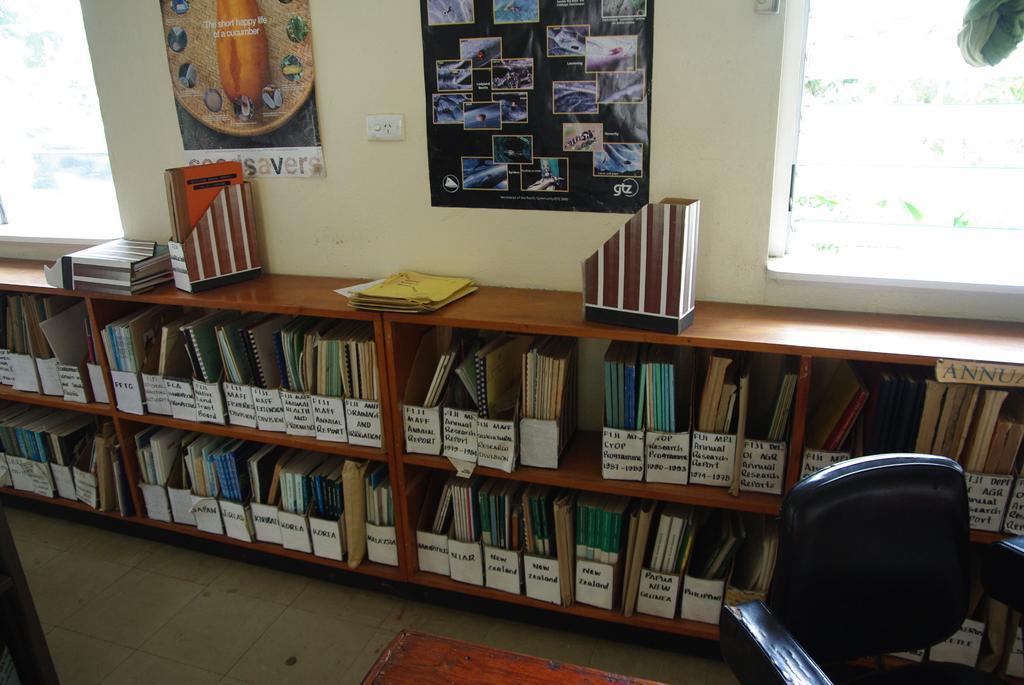Can you describe this image briefly? Here we can see a books are arranged in a wooden bookshelf. We can see a chair on the right side and a window as well. 